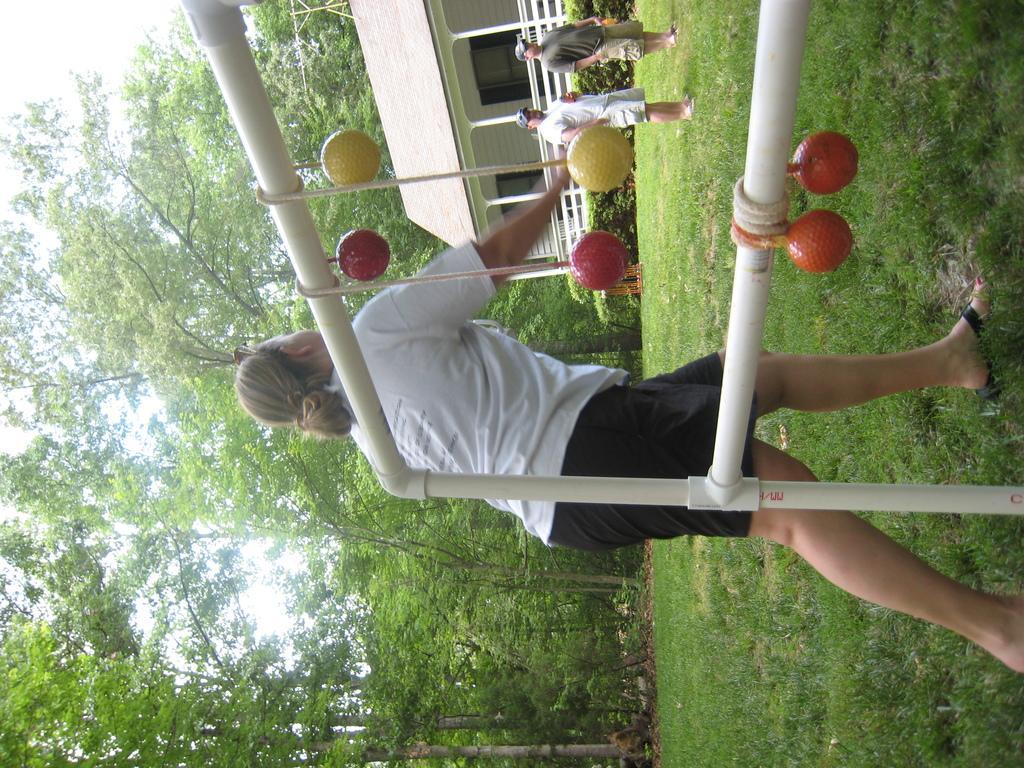Describe this image in one or two sentences. Land is covered with grass. These three people are standing. Background there are a number of trees. A house with windows. In-front this house there is a fence and plants.  